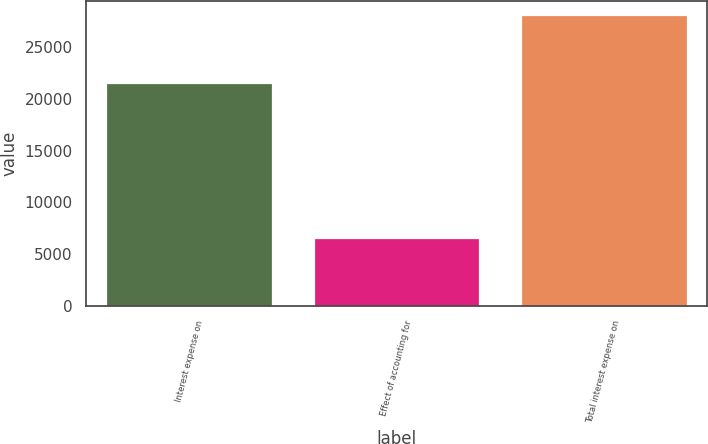<chart> <loc_0><loc_0><loc_500><loc_500><bar_chart><fcel>Interest expense on<fcel>Effect of accounting for<fcel>Total interest expense on<nl><fcel>21574<fcel>6536<fcel>28110<nl></chart> 